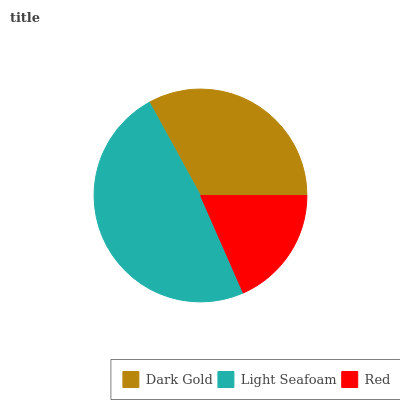Is Red the minimum?
Answer yes or no. Yes. Is Light Seafoam the maximum?
Answer yes or no. Yes. Is Light Seafoam the minimum?
Answer yes or no. No. Is Red the maximum?
Answer yes or no. No. Is Light Seafoam greater than Red?
Answer yes or no. Yes. Is Red less than Light Seafoam?
Answer yes or no. Yes. Is Red greater than Light Seafoam?
Answer yes or no. No. Is Light Seafoam less than Red?
Answer yes or no. No. Is Dark Gold the high median?
Answer yes or no. Yes. Is Dark Gold the low median?
Answer yes or no. Yes. Is Light Seafoam the high median?
Answer yes or no. No. Is Red the low median?
Answer yes or no. No. 